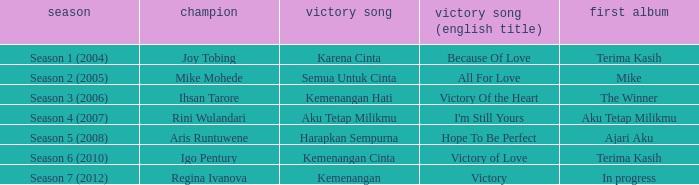Which album debuted in season 2 (2005)? Mike. 